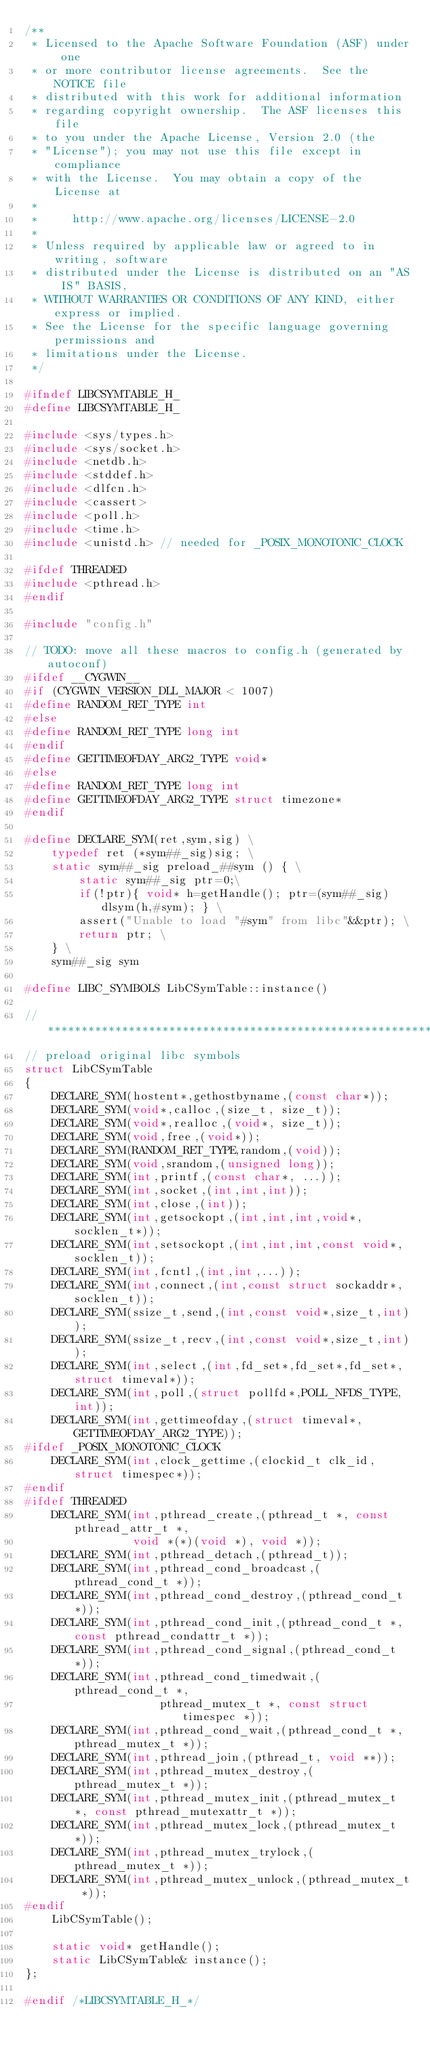Convert code to text. <code><loc_0><loc_0><loc_500><loc_500><_C_>/**
 * Licensed to the Apache Software Foundation (ASF) under one
 * or more contributor license agreements.  See the NOTICE file
 * distributed with this work for additional information
 * regarding copyright ownership.  The ASF licenses this file
 * to you under the Apache License, Version 2.0 (the
 * "License"); you may not use this file except in compliance
 * with the License.  You may obtain a copy of the License at
 *
 *     http://www.apache.org/licenses/LICENSE-2.0
 *
 * Unless required by applicable law or agreed to in writing, software
 * distributed under the License is distributed on an "AS IS" BASIS,
 * WITHOUT WARRANTIES OR CONDITIONS OF ANY KIND, either express or implied.
 * See the License for the specific language governing permissions and
 * limitations under the License.
 */

#ifndef LIBCSYMTABLE_H_
#define LIBCSYMTABLE_H_

#include <sys/types.h>
#include <sys/socket.h>
#include <netdb.h>
#include <stddef.h>
#include <dlfcn.h>
#include <cassert>
#include <poll.h>
#include <time.h>
#include <unistd.h> // needed for _POSIX_MONOTONIC_CLOCK

#ifdef THREADED
#include <pthread.h>
#endif

#include "config.h"

// TODO: move all these macros to config.h (generated by autoconf) 
#ifdef __CYGWIN__
#if (CYGWIN_VERSION_DLL_MAJOR < 1007)
#define RANDOM_RET_TYPE int
#else
#define RANDOM_RET_TYPE long int
#endif
#define GETTIMEOFDAY_ARG2_TYPE void*
#else
#define RANDOM_RET_TYPE long int
#define GETTIMEOFDAY_ARG2_TYPE struct timezone*
#endif

#define DECLARE_SYM(ret,sym,sig) \
    typedef ret (*sym##_sig)sig; \
    static sym##_sig preload_##sym () { \
        static sym##_sig ptr=0;\
        if(!ptr){ void* h=getHandle(); ptr=(sym##_sig)dlsym(h,#sym); } \
        assert("Unable to load "#sym" from libc"&&ptr); \
        return ptr; \
    } \
    sym##_sig sym

#define LIBC_SYMBOLS LibCSymTable::instance()

//******************************************************************************
// preload original libc symbols
struct LibCSymTable
{
    DECLARE_SYM(hostent*,gethostbyname,(const char*));
    DECLARE_SYM(void*,calloc,(size_t, size_t));
    DECLARE_SYM(void*,realloc,(void*, size_t));
    DECLARE_SYM(void,free,(void*));
    DECLARE_SYM(RANDOM_RET_TYPE,random,(void));
    DECLARE_SYM(void,srandom,(unsigned long));
    DECLARE_SYM(int,printf,(const char*, ...));
    DECLARE_SYM(int,socket,(int,int,int));
    DECLARE_SYM(int,close,(int));
    DECLARE_SYM(int,getsockopt,(int,int,int,void*,socklen_t*));
    DECLARE_SYM(int,setsockopt,(int,int,int,const void*,socklen_t));
    DECLARE_SYM(int,fcntl,(int,int,...));
    DECLARE_SYM(int,connect,(int,const struct sockaddr*,socklen_t));
    DECLARE_SYM(ssize_t,send,(int,const void*,size_t,int));
    DECLARE_SYM(ssize_t,recv,(int,const void*,size_t,int));
    DECLARE_SYM(int,select,(int,fd_set*,fd_set*,fd_set*,struct timeval*));
    DECLARE_SYM(int,poll,(struct pollfd*,POLL_NFDS_TYPE,int));
    DECLARE_SYM(int,gettimeofday,(struct timeval*,GETTIMEOFDAY_ARG2_TYPE));
#ifdef _POSIX_MONOTONIC_CLOCK
    DECLARE_SYM(int,clock_gettime,(clockid_t clk_id, struct timespec*));
#endif
#ifdef THREADED
    DECLARE_SYM(int,pthread_create,(pthread_t *, const pthread_attr_t *,
                void *(*)(void *), void *));
    DECLARE_SYM(int,pthread_detach,(pthread_t));
    DECLARE_SYM(int,pthread_cond_broadcast,(pthread_cond_t *));
    DECLARE_SYM(int,pthread_cond_destroy,(pthread_cond_t *));
    DECLARE_SYM(int,pthread_cond_init,(pthread_cond_t *, const pthread_condattr_t *));
    DECLARE_SYM(int,pthread_cond_signal,(pthread_cond_t *));
    DECLARE_SYM(int,pthread_cond_timedwait,(pthread_cond_t *,
                    pthread_mutex_t *, const struct timespec *));
    DECLARE_SYM(int,pthread_cond_wait,(pthread_cond_t *, pthread_mutex_t *));
    DECLARE_SYM(int,pthread_join,(pthread_t, void **));
    DECLARE_SYM(int,pthread_mutex_destroy,(pthread_mutex_t *));
    DECLARE_SYM(int,pthread_mutex_init,(pthread_mutex_t *, const pthread_mutexattr_t *));
    DECLARE_SYM(int,pthread_mutex_lock,(pthread_mutex_t *));
    DECLARE_SYM(int,pthread_mutex_trylock,(pthread_mutex_t *));
    DECLARE_SYM(int,pthread_mutex_unlock,(pthread_mutex_t *));
#endif
    LibCSymTable();
    
    static void* getHandle();
    static LibCSymTable& instance();
};

#endif /*LIBCSYMTABLE_H_*/
</code> 